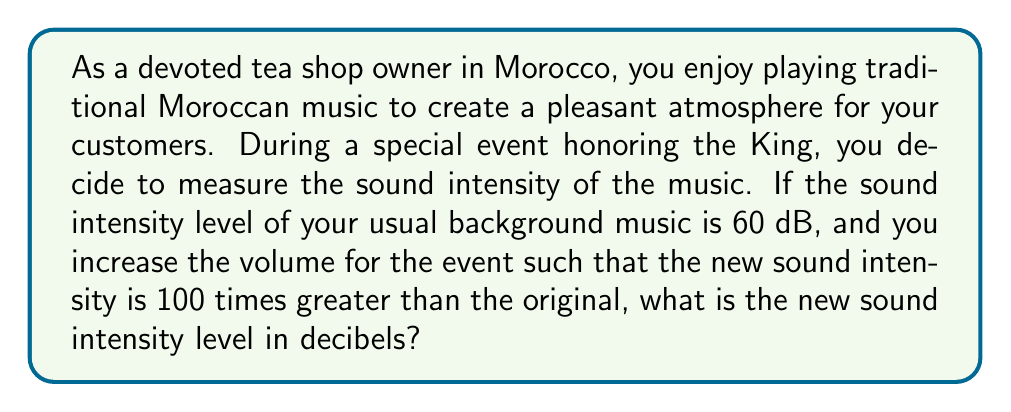Could you help me with this problem? To solve this problem, we need to use the logarithmic relationship between sound intensity and decibel levels. The formula for sound intensity level (SIL) in decibels is:

$$SIL = 10 \log_{10}\left(\frac{I}{I_0}\right)$$

Where:
$I$ is the sound intensity
$I_0$ is the reference intensity (threshold of hearing)

We're told that the original sound intensity level is 60 dB. Let's call the original intensity $I_1$ and the new intensity $I_2$.

1) For the original sound:
   $$60 = 10 \log_{10}\left(\frac{I_1}{I_0}\right)$$

2) We're told that the new intensity $I_2$ is 100 times greater than $I_1$:
   $$I_2 = 100I_1$$

3) Now, let's calculate the new sound intensity level:
   $$SIL_2 = 10 \log_{10}\left(\frac{I_2}{I_0}\right)$$
   $$= 10 \log_{10}\left(\frac{100I_1}{I_0}\right)$$
   $$= 10 \log_{10}\left(100 \cdot \frac{I_1}{I_0}\right)$$
   $$= 10 \log_{10}(100) + 10 \log_{10}\left(\frac{I_1}{I_0}\right)$$
   $$= 10 \cdot 2 + 60$$
   $$= 20 + 60$$
   $$= 80 \text{ dB}$$

Therefore, the new sound intensity level is 80 dB.
Answer: 80 dB 